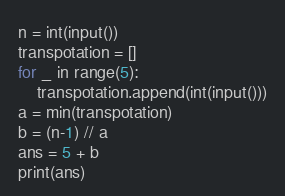Convert code to text. <code><loc_0><loc_0><loc_500><loc_500><_Python_>n = int(input())
transpotation = []
for _ in range(5):
    transpotation.append(int(input()))
a = min(transpotation)
b = (n-1) // a
ans = 5 + b
print(ans)</code> 